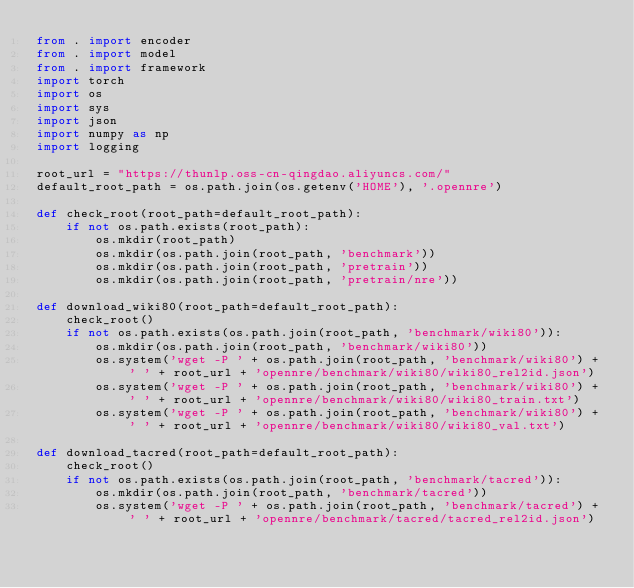<code> <loc_0><loc_0><loc_500><loc_500><_Python_>from . import encoder
from . import model
from . import framework
import torch
import os
import sys
import json
import numpy as np
import logging

root_url = "https://thunlp.oss-cn-qingdao.aliyuncs.com/"
default_root_path = os.path.join(os.getenv('HOME'), '.opennre')

def check_root(root_path=default_root_path):
    if not os.path.exists(root_path):
        os.mkdir(root_path)
        os.mkdir(os.path.join(root_path, 'benchmark'))
        os.mkdir(os.path.join(root_path, 'pretrain'))
        os.mkdir(os.path.join(root_path, 'pretrain/nre'))

def download_wiki80(root_path=default_root_path):
    check_root()
    if not os.path.exists(os.path.join(root_path, 'benchmark/wiki80')):
        os.mkdir(os.path.join(root_path, 'benchmark/wiki80'))
        os.system('wget -P ' + os.path.join(root_path, 'benchmark/wiki80') + ' ' + root_url + 'opennre/benchmark/wiki80/wiki80_rel2id.json')
        os.system('wget -P ' + os.path.join(root_path, 'benchmark/wiki80') + ' ' + root_url + 'opennre/benchmark/wiki80/wiki80_train.txt')
        os.system('wget -P ' + os.path.join(root_path, 'benchmark/wiki80') + ' ' + root_url + 'opennre/benchmark/wiki80/wiki80_val.txt')

def download_tacred(root_path=default_root_path):
    check_root()
    if not os.path.exists(os.path.join(root_path, 'benchmark/tacred')):
        os.mkdir(os.path.join(root_path, 'benchmark/tacred'))
        os.system('wget -P ' + os.path.join(root_path, 'benchmark/tacred') + ' ' + root_url + 'opennre/benchmark/tacred/tacred_rel2id.json')</code> 